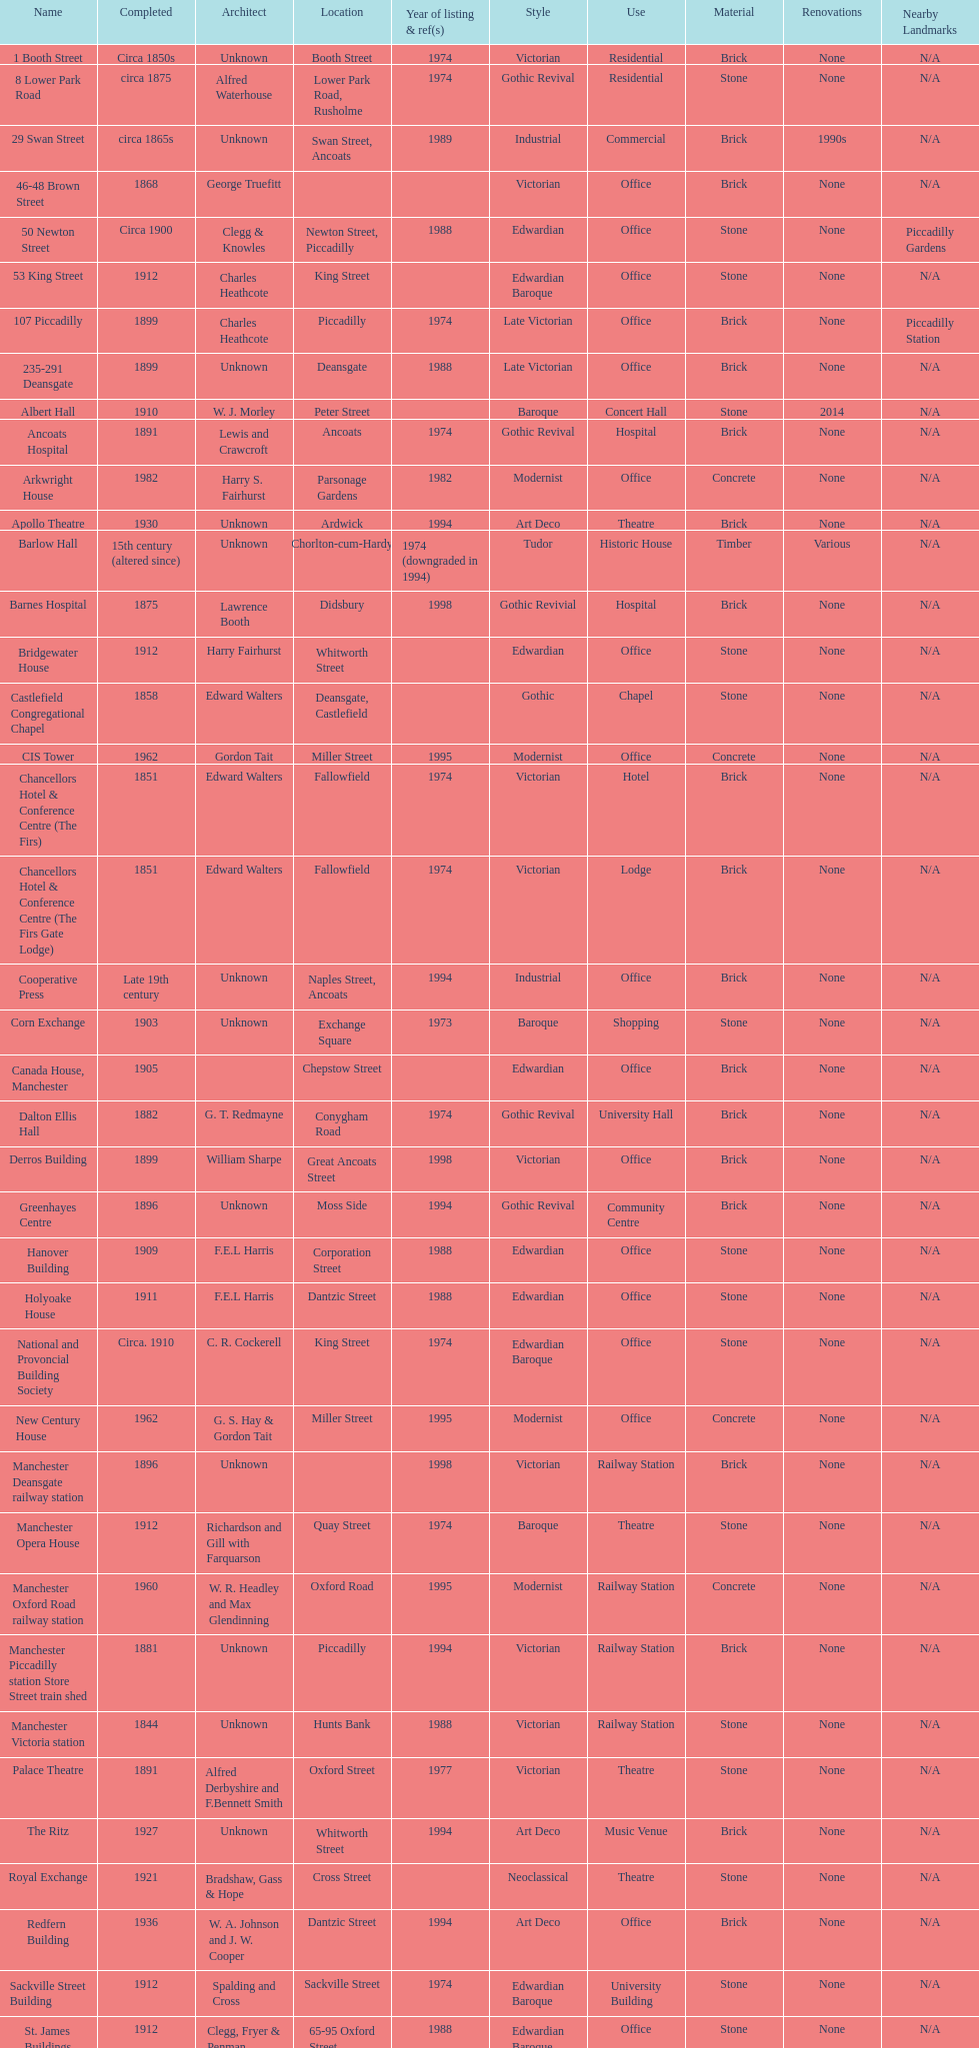What is the difference, in years, between the completion dates of 53 king street and castlefield congregational chapel? 54 years. 